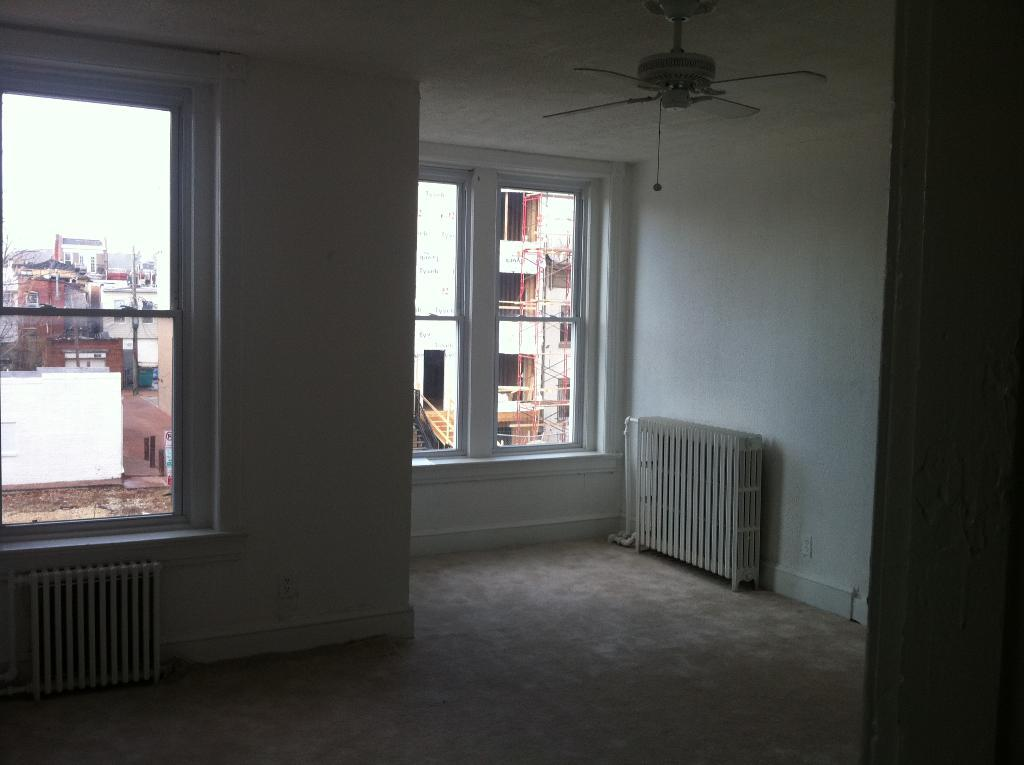What type of space is depicted in the image? The image shows the inside of a room. What can be found on the ceiling of the room? There is a fan on the ceiling of the room. Are there any sources of natural light in the room? Yes, there are windows in the room. What can be seen through the windows? Buildings are visible through the windows. What type of yarn is being used by the lawyer in the image? There is no lawyer or yarn present in the image. What thrilling activity is taking place in the room? The image does not depict any thrilling activities; it shows a room with a fan and windows. 